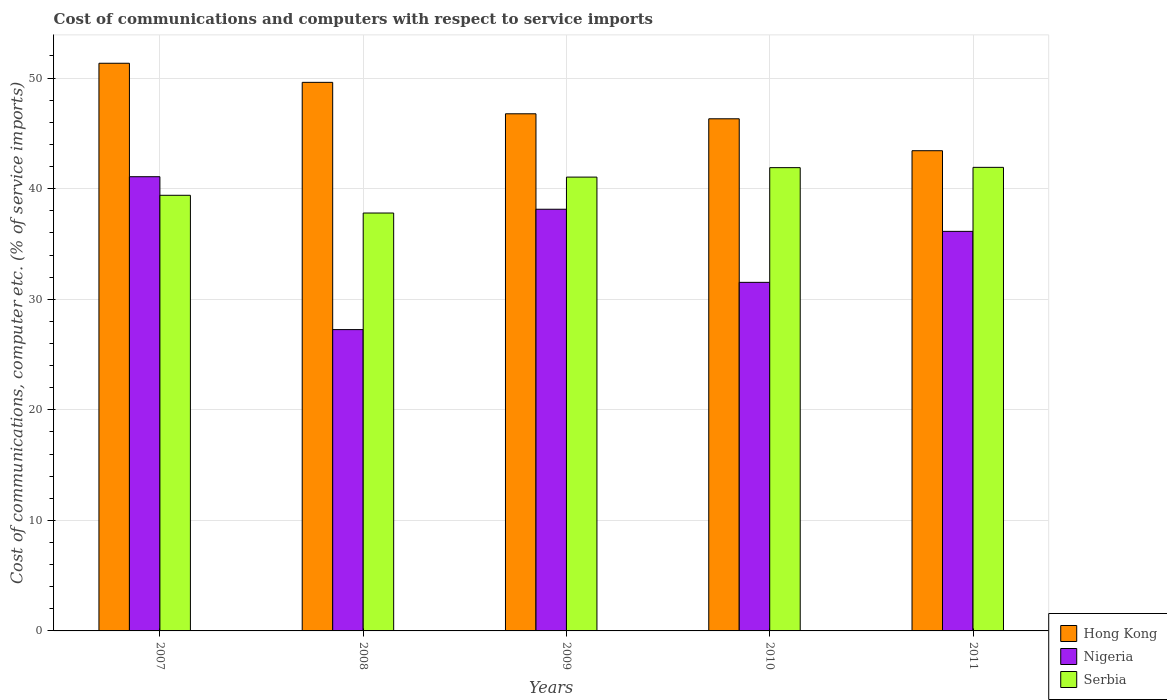Are the number of bars per tick equal to the number of legend labels?
Offer a very short reply. Yes. How many bars are there on the 1st tick from the right?
Ensure brevity in your answer.  3. What is the label of the 5th group of bars from the left?
Provide a succinct answer. 2011. In how many cases, is the number of bars for a given year not equal to the number of legend labels?
Offer a terse response. 0. What is the cost of communications and computers in Hong Kong in 2011?
Offer a very short reply. 43.43. Across all years, what is the maximum cost of communications and computers in Serbia?
Offer a terse response. 41.93. Across all years, what is the minimum cost of communications and computers in Hong Kong?
Offer a terse response. 43.43. In which year was the cost of communications and computers in Serbia maximum?
Your response must be concise. 2011. What is the total cost of communications and computers in Serbia in the graph?
Offer a very short reply. 202.07. What is the difference between the cost of communications and computers in Nigeria in 2009 and that in 2010?
Your answer should be very brief. 6.61. What is the difference between the cost of communications and computers in Nigeria in 2007 and the cost of communications and computers in Hong Kong in 2008?
Your answer should be very brief. -8.53. What is the average cost of communications and computers in Serbia per year?
Provide a short and direct response. 40.41. In the year 2010, what is the difference between the cost of communications and computers in Serbia and cost of communications and computers in Nigeria?
Your response must be concise. 10.37. What is the ratio of the cost of communications and computers in Serbia in 2007 to that in 2008?
Give a very brief answer. 1.04. What is the difference between the highest and the second highest cost of communications and computers in Nigeria?
Your answer should be compact. 2.94. What is the difference between the highest and the lowest cost of communications and computers in Hong Kong?
Make the answer very short. 7.91. Is the sum of the cost of communications and computers in Serbia in 2008 and 2011 greater than the maximum cost of communications and computers in Hong Kong across all years?
Offer a very short reply. Yes. What does the 1st bar from the left in 2011 represents?
Provide a short and direct response. Hong Kong. What does the 3rd bar from the right in 2010 represents?
Keep it short and to the point. Hong Kong. Is it the case that in every year, the sum of the cost of communications and computers in Serbia and cost of communications and computers in Hong Kong is greater than the cost of communications and computers in Nigeria?
Your response must be concise. Yes. How many bars are there?
Your response must be concise. 15. Are the values on the major ticks of Y-axis written in scientific E-notation?
Give a very brief answer. No. How many legend labels are there?
Ensure brevity in your answer.  3. What is the title of the graph?
Offer a very short reply. Cost of communications and computers with respect to service imports. Does "Ethiopia" appear as one of the legend labels in the graph?
Ensure brevity in your answer.  No. What is the label or title of the Y-axis?
Make the answer very short. Cost of communications, computer etc. (% of service imports). What is the Cost of communications, computer etc. (% of service imports) of Hong Kong in 2007?
Ensure brevity in your answer.  51.34. What is the Cost of communications, computer etc. (% of service imports) of Nigeria in 2007?
Offer a terse response. 41.08. What is the Cost of communications, computer etc. (% of service imports) of Serbia in 2007?
Make the answer very short. 39.4. What is the Cost of communications, computer etc. (% of service imports) of Hong Kong in 2008?
Your answer should be very brief. 49.62. What is the Cost of communications, computer etc. (% of service imports) of Nigeria in 2008?
Provide a succinct answer. 27.25. What is the Cost of communications, computer etc. (% of service imports) in Serbia in 2008?
Give a very brief answer. 37.8. What is the Cost of communications, computer etc. (% of service imports) in Hong Kong in 2009?
Ensure brevity in your answer.  46.77. What is the Cost of communications, computer etc. (% of service imports) in Nigeria in 2009?
Keep it short and to the point. 38.14. What is the Cost of communications, computer etc. (% of service imports) of Serbia in 2009?
Offer a terse response. 41.05. What is the Cost of communications, computer etc. (% of service imports) of Hong Kong in 2010?
Your response must be concise. 46.32. What is the Cost of communications, computer etc. (% of service imports) of Nigeria in 2010?
Your answer should be compact. 31.53. What is the Cost of communications, computer etc. (% of service imports) of Serbia in 2010?
Ensure brevity in your answer.  41.9. What is the Cost of communications, computer etc. (% of service imports) of Hong Kong in 2011?
Your answer should be very brief. 43.43. What is the Cost of communications, computer etc. (% of service imports) in Nigeria in 2011?
Provide a succinct answer. 36.14. What is the Cost of communications, computer etc. (% of service imports) of Serbia in 2011?
Provide a succinct answer. 41.93. Across all years, what is the maximum Cost of communications, computer etc. (% of service imports) of Hong Kong?
Your answer should be compact. 51.34. Across all years, what is the maximum Cost of communications, computer etc. (% of service imports) of Nigeria?
Your answer should be compact. 41.08. Across all years, what is the maximum Cost of communications, computer etc. (% of service imports) of Serbia?
Your answer should be very brief. 41.93. Across all years, what is the minimum Cost of communications, computer etc. (% of service imports) in Hong Kong?
Keep it short and to the point. 43.43. Across all years, what is the minimum Cost of communications, computer etc. (% of service imports) of Nigeria?
Ensure brevity in your answer.  27.25. Across all years, what is the minimum Cost of communications, computer etc. (% of service imports) in Serbia?
Offer a very short reply. 37.8. What is the total Cost of communications, computer etc. (% of service imports) of Hong Kong in the graph?
Your answer should be very brief. 237.48. What is the total Cost of communications, computer etc. (% of service imports) in Nigeria in the graph?
Your answer should be compact. 174.14. What is the total Cost of communications, computer etc. (% of service imports) of Serbia in the graph?
Make the answer very short. 202.07. What is the difference between the Cost of communications, computer etc. (% of service imports) in Hong Kong in 2007 and that in 2008?
Ensure brevity in your answer.  1.73. What is the difference between the Cost of communications, computer etc. (% of service imports) of Nigeria in 2007 and that in 2008?
Ensure brevity in your answer.  13.83. What is the difference between the Cost of communications, computer etc. (% of service imports) of Serbia in 2007 and that in 2008?
Offer a terse response. 1.6. What is the difference between the Cost of communications, computer etc. (% of service imports) of Hong Kong in 2007 and that in 2009?
Offer a terse response. 4.57. What is the difference between the Cost of communications, computer etc. (% of service imports) of Nigeria in 2007 and that in 2009?
Your response must be concise. 2.94. What is the difference between the Cost of communications, computer etc. (% of service imports) of Serbia in 2007 and that in 2009?
Offer a terse response. -1.65. What is the difference between the Cost of communications, computer etc. (% of service imports) of Hong Kong in 2007 and that in 2010?
Make the answer very short. 5.02. What is the difference between the Cost of communications, computer etc. (% of service imports) in Nigeria in 2007 and that in 2010?
Your answer should be very brief. 9.55. What is the difference between the Cost of communications, computer etc. (% of service imports) in Serbia in 2007 and that in 2010?
Provide a succinct answer. -2.5. What is the difference between the Cost of communications, computer etc. (% of service imports) of Hong Kong in 2007 and that in 2011?
Offer a very short reply. 7.91. What is the difference between the Cost of communications, computer etc. (% of service imports) of Nigeria in 2007 and that in 2011?
Offer a very short reply. 4.94. What is the difference between the Cost of communications, computer etc. (% of service imports) in Serbia in 2007 and that in 2011?
Your answer should be compact. -2.53. What is the difference between the Cost of communications, computer etc. (% of service imports) of Hong Kong in 2008 and that in 2009?
Give a very brief answer. 2.84. What is the difference between the Cost of communications, computer etc. (% of service imports) in Nigeria in 2008 and that in 2009?
Offer a terse response. -10.88. What is the difference between the Cost of communications, computer etc. (% of service imports) in Serbia in 2008 and that in 2009?
Make the answer very short. -3.25. What is the difference between the Cost of communications, computer etc. (% of service imports) in Hong Kong in 2008 and that in 2010?
Provide a short and direct response. 3.3. What is the difference between the Cost of communications, computer etc. (% of service imports) in Nigeria in 2008 and that in 2010?
Keep it short and to the point. -4.27. What is the difference between the Cost of communications, computer etc. (% of service imports) in Serbia in 2008 and that in 2010?
Provide a short and direct response. -4.1. What is the difference between the Cost of communications, computer etc. (% of service imports) of Hong Kong in 2008 and that in 2011?
Offer a terse response. 6.18. What is the difference between the Cost of communications, computer etc. (% of service imports) in Nigeria in 2008 and that in 2011?
Ensure brevity in your answer.  -8.88. What is the difference between the Cost of communications, computer etc. (% of service imports) in Serbia in 2008 and that in 2011?
Your answer should be very brief. -4.13. What is the difference between the Cost of communications, computer etc. (% of service imports) in Hong Kong in 2009 and that in 2010?
Keep it short and to the point. 0.45. What is the difference between the Cost of communications, computer etc. (% of service imports) of Nigeria in 2009 and that in 2010?
Keep it short and to the point. 6.61. What is the difference between the Cost of communications, computer etc. (% of service imports) in Serbia in 2009 and that in 2010?
Your answer should be very brief. -0.85. What is the difference between the Cost of communications, computer etc. (% of service imports) of Hong Kong in 2009 and that in 2011?
Keep it short and to the point. 3.34. What is the difference between the Cost of communications, computer etc. (% of service imports) of Nigeria in 2009 and that in 2011?
Provide a succinct answer. 2. What is the difference between the Cost of communications, computer etc. (% of service imports) in Serbia in 2009 and that in 2011?
Offer a very short reply. -0.88. What is the difference between the Cost of communications, computer etc. (% of service imports) of Hong Kong in 2010 and that in 2011?
Offer a very short reply. 2.89. What is the difference between the Cost of communications, computer etc. (% of service imports) of Nigeria in 2010 and that in 2011?
Offer a terse response. -4.61. What is the difference between the Cost of communications, computer etc. (% of service imports) in Serbia in 2010 and that in 2011?
Your response must be concise. -0.03. What is the difference between the Cost of communications, computer etc. (% of service imports) in Hong Kong in 2007 and the Cost of communications, computer etc. (% of service imports) in Nigeria in 2008?
Offer a terse response. 24.09. What is the difference between the Cost of communications, computer etc. (% of service imports) of Hong Kong in 2007 and the Cost of communications, computer etc. (% of service imports) of Serbia in 2008?
Your answer should be compact. 13.55. What is the difference between the Cost of communications, computer etc. (% of service imports) of Nigeria in 2007 and the Cost of communications, computer etc. (% of service imports) of Serbia in 2008?
Your answer should be very brief. 3.28. What is the difference between the Cost of communications, computer etc. (% of service imports) in Hong Kong in 2007 and the Cost of communications, computer etc. (% of service imports) in Nigeria in 2009?
Provide a short and direct response. 13.2. What is the difference between the Cost of communications, computer etc. (% of service imports) of Hong Kong in 2007 and the Cost of communications, computer etc. (% of service imports) of Serbia in 2009?
Make the answer very short. 10.3. What is the difference between the Cost of communications, computer etc. (% of service imports) in Nigeria in 2007 and the Cost of communications, computer etc. (% of service imports) in Serbia in 2009?
Make the answer very short. 0.04. What is the difference between the Cost of communications, computer etc. (% of service imports) of Hong Kong in 2007 and the Cost of communications, computer etc. (% of service imports) of Nigeria in 2010?
Provide a short and direct response. 19.82. What is the difference between the Cost of communications, computer etc. (% of service imports) in Hong Kong in 2007 and the Cost of communications, computer etc. (% of service imports) in Serbia in 2010?
Make the answer very short. 9.44. What is the difference between the Cost of communications, computer etc. (% of service imports) in Nigeria in 2007 and the Cost of communications, computer etc. (% of service imports) in Serbia in 2010?
Make the answer very short. -0.82. What is the difference between the Cost of communications, computer etc. (% of service imports) of Hong Kong in 2007 and the Cost of communications, computer etc. (% of service imports) of Nigeria in 2011?
Your answer should be very brief. 15.2. What is the difference between the Cost of communications, computer etc. (% of service imports) in Hong Kong in 2007 and the Cost of communications, computer etc. (% of service imports) in Serbia in 2011?
Offer a very short reply. 9.41. What is the difference between the Cost of communications, computer etc. (% of service imports) of Nigeria in 2007 and the Cost of communications, computer etc. (% of service imports) of Serbia in 2011?
Provide a short and direct response. -0.85. What is the difference between the Cost of communications, computer etc. (% of service imports) in Hong Kong in 2008 and the Cost of communications, computer etc. (% of service imports) in Nigeria in 2009?
Your answer should be compact. 11.48. What is the difference between the Cost of communications, computer etc. (% of service imports) of Hong Kong in 2008 and the Cost of communications, computer etc. (% of service imports) of Serbia in 2009?
Keep it short and to the point. 8.57. What is the difference between the Cost of communications, computer etc. (% of service imports) of Nigeria in 2008 and the Cost of communications, computer etc. (% of service imports) of Serbia in 2009?
Keep it short and to the point. -13.79. What is the difference between the Cost of communications, computer etc. (% of service imports) in Hong Kong in 2008 and the Cost of communications, computer etc. (% of service imports) in Nigeria in 2010?
Offer a terse response. 18.09. What is the difference between the Cost of communications, computer etc. (% of service imports) of Hong Kong in 2008 and the Cost of communications, computer etc. (% of service imports) of Serbia in 2010?
Offer a very short reply. 7.71. What is the difference between the Cost of communications, computer etc. (% of service imports) of Nigeria in 2008 and the Cost of communications, computer etc. (% of service imports) of Serbia in 2010?
Make the answer very short. -14.65. What is the difference between the Cost of communications, computer etc. (% of service imports) of Hong Kong in 2008 and the Cost of communications, computer etc. (% of service imports) of Nigeria in 2011?
Your answer should be compact. 13.48. What is the difference between the Cost of communications, computer etc. (% of service imports) in Hong Kong in 2008 and the Cost of communications, computer etc. (% of service imports) in Serbia in 2011?
Offer a terse response. 7.69. What is the difference between the Cost of communications, computer etc. (% of service imports) of Nigeria in 2008 and the Cost of communications, computer etc. (% of service imports) of Serbia in 2011?
Your response must be concise. -14.67. What is the difference between the Cost of communications, computer etc. (% of service imports) of Hong Kong in 2009 and the Cost of communications, computer etc. (% of service imports) of Nigeria in 2010?
Make the answer very short. 15.24. What is the difference between the Cost of communications, computer etc. (% of service imports) of Hong Kong in 2009 and the Cost of communications, computer etc. (% of service imports) of Serbia in 2010?
Offer a terse response. 4.87. What is the difference between the Cost of communications, computer etc. (% of service imports) of Nigeria in 2009 and the Cost of communications, computer etc. (% of service imports) of Serbia in 2010?
Your answer should be compact. -3.76. What is the difference between the Cost of communications, computer etc. (% of service imports) of Hong Kong in 2009 and the Cost of communications, computer etc. (% of service imports) of Nigeria in 2011?
Offer a terse response. 10.63. What is the difference between the Cost of communications, computer etc. (% of service imports) of Hong Kong in 2009 and the Cost of communications, computer etc. (% of service imports) of Serbia in 2011?
Offer a terse response. 4.84. What is the difference between the Cost of communications, computer etc. (% of service imports) in Nigeria in 2009 and the Cost of communications, computer etc. (% of service imports) in Serbia in 2011?
Make the answer very short. -3.79. What is the difference between the Cost of communications, computer etc. (% of service imports) in Hong Kong in 2010 and the Cost of communications, computer etc. (% of service imports) in Nigeria in 2011?
Keep it short and to the point. 10.18. What is the difference between the Cost of communications, computer etc. (% of service imports) in Hong Kong in 2010 and the Cost of communications, computer etc. (% of service imports) in Serbia in 2011?
Ensure brevity in your answer.  4.39. What is the difference between the Cost of communications, computer etc. (% of service imports) in Nigeria in 2010 and the Cost of communications, computer etc. (% of service imports) in Serbia in 2011?
Offer a terse response. -10.4. What is the average Cost of communications, computer etc. (% of service imports) in Hong Kong per year?
Ensure brevity in your answer.  47.5. What is the average Cost of communications, computer etc. (% of service imports) in Nigeria per year?
Keep it short and to the point. 34.83. What is the average Cost of communications, computer etc. (% of service imports) of Serbia per year?
Provide a short and direct response. 40.41. In the year 2007, what is the difference between the Cost of communications, computer etc. (% of service imports) in Hong Kong and Cost of communications, computer etc. (% of service imports) in Nigeria?
Your answer should be compact. 10.26. In the year 2007, what is the difference between the Cost of communications, computer etc. (% of service imports) in Hong Kong and Cost of communications, computer etc. (% of service imports) in Serbia?
Offer a very short reply. 11.94. In the year 2007, what is the difference between the Cost of communications, computer etc. (% of service imports) of Nigeria and Cost of communications, computer etc. (% of service imports) of Serbia?
Your response must be concise. 1.68. In the year 2008, what is the difference between the Cost of communications, computer etc. (% of service imports) of Hong Kong and Cost of communications, computer etc. (% of service imports) of Nigeria?
Make the answer very short. 22.36. In the year 2008, what is the difference between the Cost of communications, computer etc. (% of service imports) in Hong Kong and Cost of communications, computer etc. (% of service imports) in Serbia?
Provide a succinct answer. 11.82. In the year 2008, what is the difference between the Cost of communications, computer etc. (% of service imports) of Nigeria and Cost of communications, computer etc. (% of service imports) of Serbia?
Your answer should be very brief. -10.54. In the year 2009, what is the difference between the Cost of communications, computer etc. (% of service imports) in Hong Kong and Cost of communications, computer etc. (% of service imports) in Nigeria?
Make the answer very short. 8.63. In the year 2009, what is the difference between the Cost of communications, computer etc. (% of service imports) of Hong Kong and Cost of communications, computer etc. (% of service imports) of Serbia?
Your response must be concise. 5.73. In the year 2009, what is the difference between the Cost of communications, computer etc. (% of service imports) in Nigeria and Cost of communications, computer etc. (% of service imports) in Serbia?
Make the answer very short. -2.91. In the year 2010, what is the difference between the Cost of communications, computer etc. (% of service imports) in Hong Kong and Cost of communications, computer etc. (% of service imports) in Nigeria?
Provide a short and direct response. 14.79. In the year 2010, what is the difference between the Cost of communications, computer etc. (% of service imports) of Hong Kong and Cost of communications, computer etc. (% of service imports) of Serbia?
Make the answer very short. 4.42. In the year 2010, what is the difference between the Cost of communications, computer etc. (% of service imports) of Nigeria and Cost of communications, computer etc. (% of service imports) of Serbia?
Keep it short and to the point. -10.37. In the year 2011, what is the difference between the Cost of communications, computer etc. (% of service imports) in Hong Kong and Cost of communications, computer etc. (% of service imports) in Nigeria?
Offer a terse response. 7.29. In the year 2011, what is the difference between the Cost of communications, computer etc. (% of service imports) in Hong Kong and Cost of communications, computer etc. (% of service imports) in Serbia?
Make the answer very short. 1.5. In the year 2011, what is the difference between the Cost of communications, computer etc. (% of service imports) of Nigeria and Cost of communications, computer etc. (% of service imports) of Serbia?
Keep it short and to the point. -5.79. What is the ratio of the Cost of communications, computer etc. (% of service imports) in Hong Kong in 2007 to that in 2008?
Ensure brevity in your answer.  1.03. What is the ratio of the Cost of communications, computer etc. (% of service imports) of Nigeria in 2007 to that in 2008?
Give a very brief answer. 1.51. What is the ratio of the Cost of communications, computer etc. (% of service imports) of Serbia in 2007 to that in 2008?
Your answer should be compact. 1.04. What is the ratio of the Cost of communications, computer etc. (% of service imports) of Hong Kong in 2007 to that in 2009?
Offer a very short reply. 1.1. What is the ratio of the Cost of communications, computer etc. (% of service imports) in Nigeria in 2007 to that in 2009?
Your answer should be compact. 1.08. What is the ratio of the Cost of communications, computer etc. (% of service imports) of Serbia in 2007 to that in 2009?
Your response must be concise. 0.96. What is the ratio of the Cost of communications, computer etc. (% of service imports) in Hong Kong in 2007 to that in 2010?
Make the answer very short. 1.11. What is the ratio of the Cost of communications, computer etc. (% of service imports) of Nigeria in 2007 to that in 2010?
Offer a terse response. 1.3. What is the ratio of the Cost of communications, computer etc. (% of service imports) of Serbia in 2007 to that in 2010?
Your answer should be very brief. 0.94. What is the ratio of the Cost of communications, computer etc. (% of service imports) in Hong Kong in 2007 to that in 2011?
Offer a terse response. 1.18. What is the ratio of the Cost of communications, computer etc. (% of service imports) of Nigeria in 2007 to that in 2011?
Your answer should be compact. 1.14. What is the ratio of the Cost of communications, computer etc. (% of service imports) of Serbia in 2007 to that in 2011?
Keep it short and to the point. 0.94. What is the ratio of the Cost of communications, computer etc. (% of service imports) of Hong Kong in 2008 to that in 2009?
Offer a terse response. 1.06. What is the ratio of the Cost of communications, computer etc. (% of service imports) in Nigeria in 2008 to that in 2009?
Offer a terse response. 0.71. What is the ratio of the Cost of communications, computer etc. (% of service imports) in Serbia in 2008 to that in 2009?
Provide a succinct answer. 0.92. What is the ratio of the Cost of communications, computer etc. (% of service imports) in Hong Kong in 2008 to that in 2010?
Give a very brief answer. 1.07. What is the ratio of the Cost of communications, computer etc. (% of service imports) of Nigeria in 2008 to that in 2010?
Offer a very short reply. 0.86. What is the ratio of the Cost of communications, computer etc. (% of service imports) of Serbia in 2008 to that in 2010?
Keep it short and to the point. 0.9. What is the ratio of the Cost of communications, computer etc. (% of service imports) of Hong Kong in 2008 to that in 2011?
Provide a short and direct response. 1.14. What is the ratio of the Cost of communications, computer etc. (% of service imports) in Nigeria in 2008 to that in 2011?
Offer a very short reply. 0.75. What is the ratio of the Cost of communications, computer etc. (% of service imports) in Serbia in 2008 to that in 2011?
Your answer should be very brief. 0.9. What is the ratio of the Cost of communications, computer etc. (% of service imports) in Hong Kong in 2009 to that in 2010?
Offer a very short reply. 1.01. What is the ratio of the Cost of communications, computer etc. (% of service imports) of Nigeria in 2009 to that in 2010?
Offer a terse response. 1.21. What is the ratio of the Cost of communications, computer etc. (% of service imports) in Serbia in 2009 to that in 2010?
Provide a short and direct response. 0.98. What is the ratio of the Cost of communications, computer etc. (% of service imports) of Nigeria in 2009 to that in 2011?
Offer a very short reply. 1.06. What is the ratio of the Cost of communications, computer etc. (% of service imports) of Hong Kong in 2010 to that in 2011?
Give a very brief answer. 1.07. What is the ratio of the Cost of communications, computer etc. (% of service imports) in Nigeria in 2010 to that in 2011?
Keep it short and to the point. 0.87. What is the difference between the highest and the second highest Cost of communications, computer etc. (% of service imports) in Hong Kong?
Provide a succinct answer. 1.73. What is the difference between the highest and the second highest Cost of communications, computer etc. (% of service imports) in Nigeria?
Offer a terse response. 2.94. What is the difference between the highest and the second highest Cost of communications, computer etc. (% of service imports) in Serbia?
Make the answer very short. 0.03. What is the difference between the highest and the lowest Cost of communications, computer etc. (% of service imports) in Hong Kong?
Provide a succinct answer. 7.91. What is the difference between the highest and the lowest Cost of communications, computer etc. (% of service imports) in Nigeria?
Your answer should be compact. 13.83. What is the difference between the highest and the lowest Cost of communications, computer etc. (% of service imports) in Serbia?
Your answer should be very brief. 4.13. 